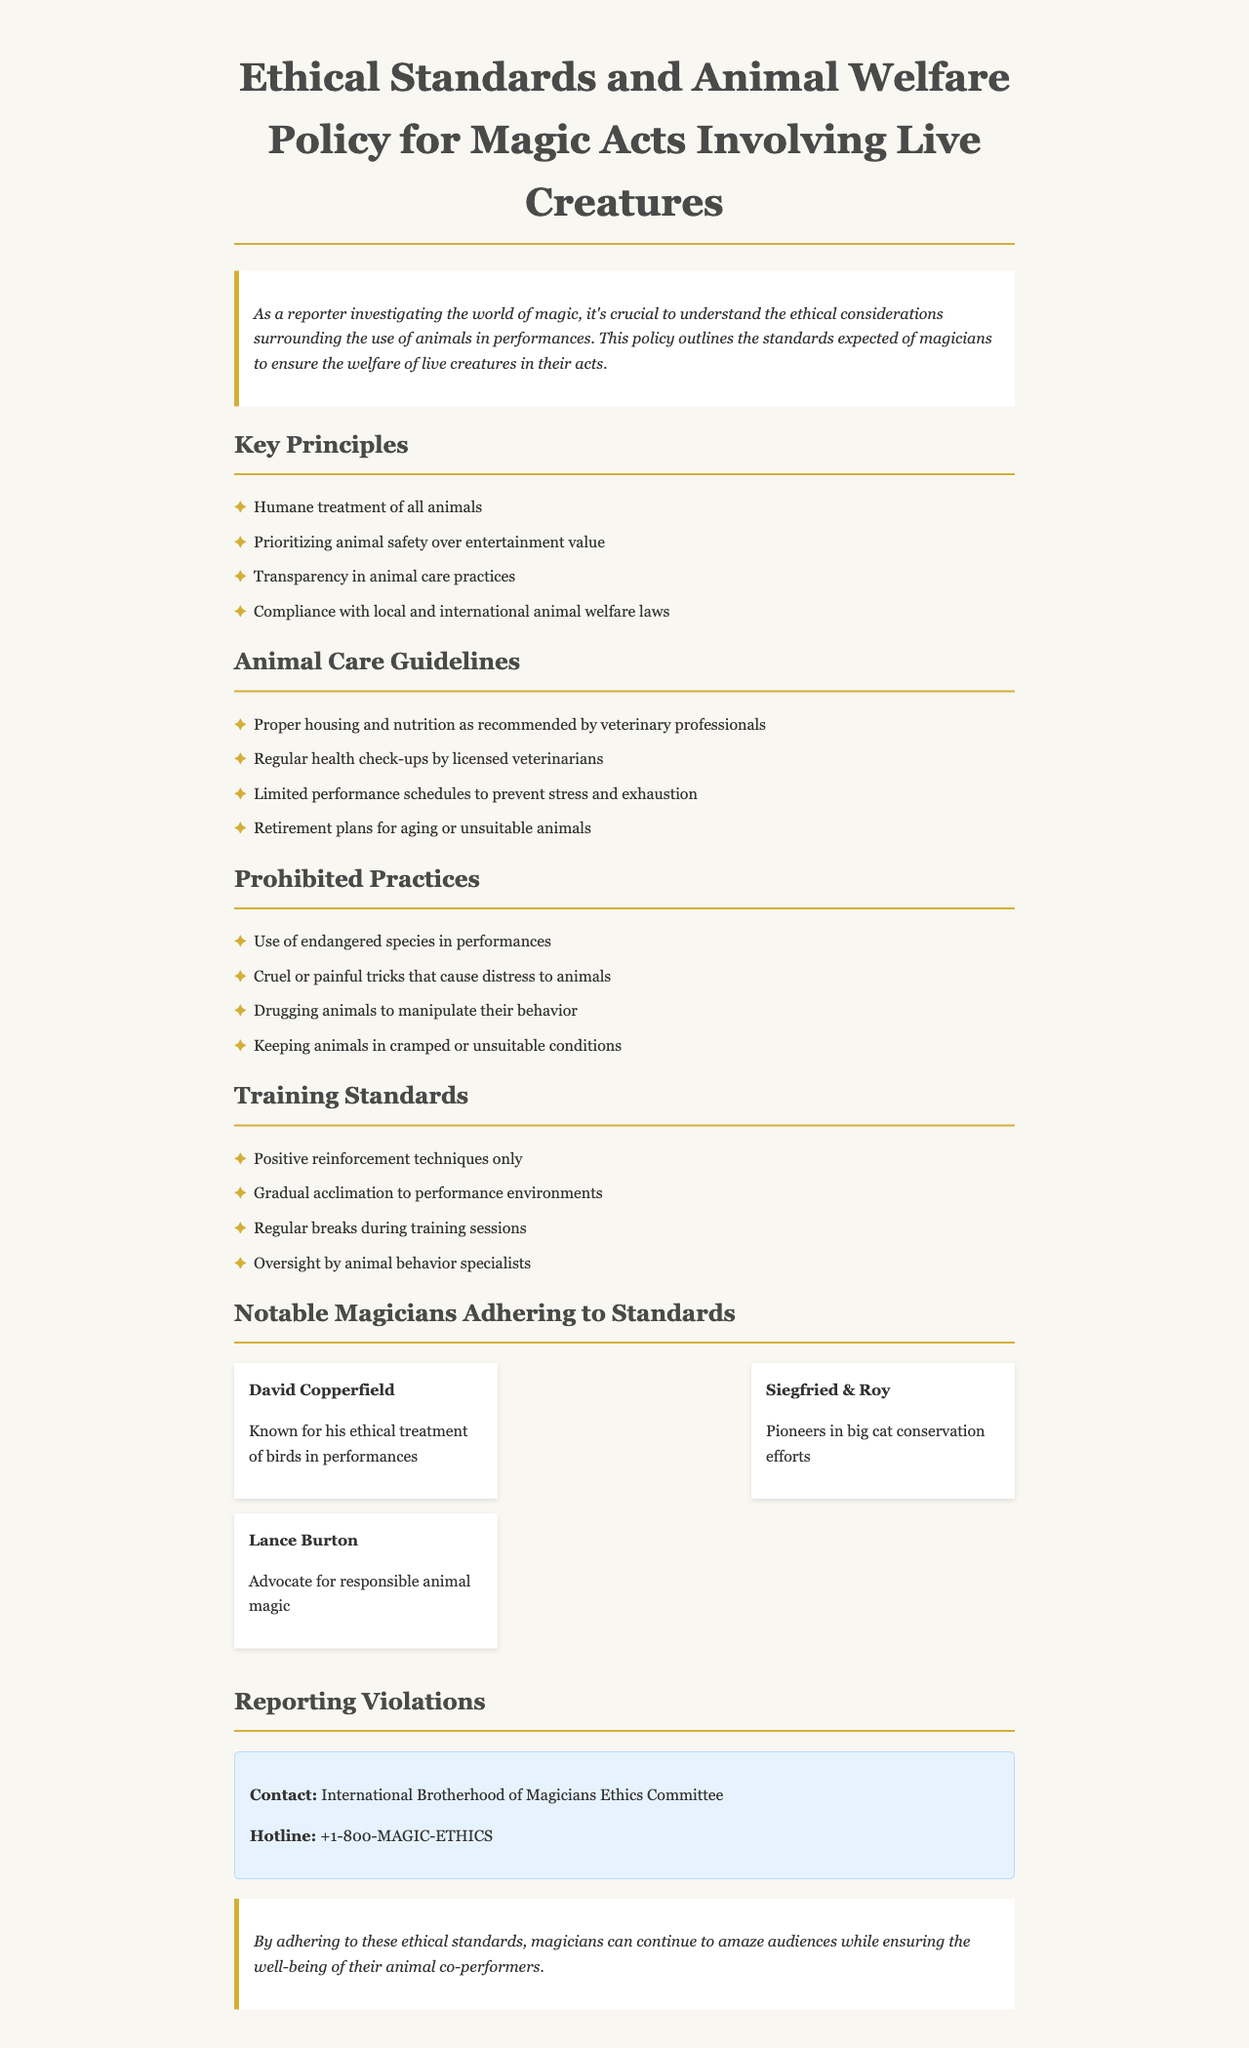What are the key principles for animal welfare? The key principles are listed under "Key Principles" in the document, which include humane treatment, animal safety, transparency, and compliance with laws.
Answer: Humane treatment of all animals, Prioritizing animal safety over entertainment value, Transparency in animal care practices, Compliance with local and international animal welfare laws Who is known for ethical treatment of birds? The document mentions David Copperfield as known for his ethical treatment of birds in performances.
Answer: David Copperfield What should be limited to prevent stress in animals? The document states that performance schedules should be limited to prevent stress and exhaustion in animals.
Answer: Limited performance schedules What practices are prohibited according to the policy? The policy outlines prohibited practices, such as the use of endangered species and drugging animals.
Answer: Use of endangered species in performances, Cruel or painful tricks that cause distress to animals, Drugging animals to manipulate their behavior, Keeping animals in cramped or unsuitable conditions Which training technique is allowed? The document states that only positive reinforcement techniques are allowed in training standards.
Answer: Positive reinforcement techniques only What is the contact for reporting violations? The document provides a contact number for reporting violations, which is listed under "Reporting Violations."
Answer: +1-800-MAGIC-ETHICS Who are Siegfried & Roy? The document describes Siegfried & Roy as pioneers in big cat conservation efforts.
Answer: Pioneers in big cat conservation efforts What is one guideline for animal care? The policy outlines proper housing as a guideline for animal care under "Animal Care Guidelines."
Answer: Proper housing and nutrition as recommended by veterinary professionals 